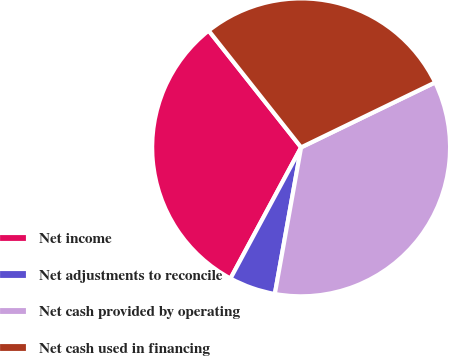Convert chart to OTSL. <chart><loc_0><loc_0><loc_500><loc_500><pie_chart><fcel>Net income<fcel>Net adjustments to reconcile<fcel>Net cash provided by operating<fcel>Net cash used in financing<nl><fcel>31.48%<fcel>5.04%<fcel>35.01%<fcel>28.48%<nl></chart> 